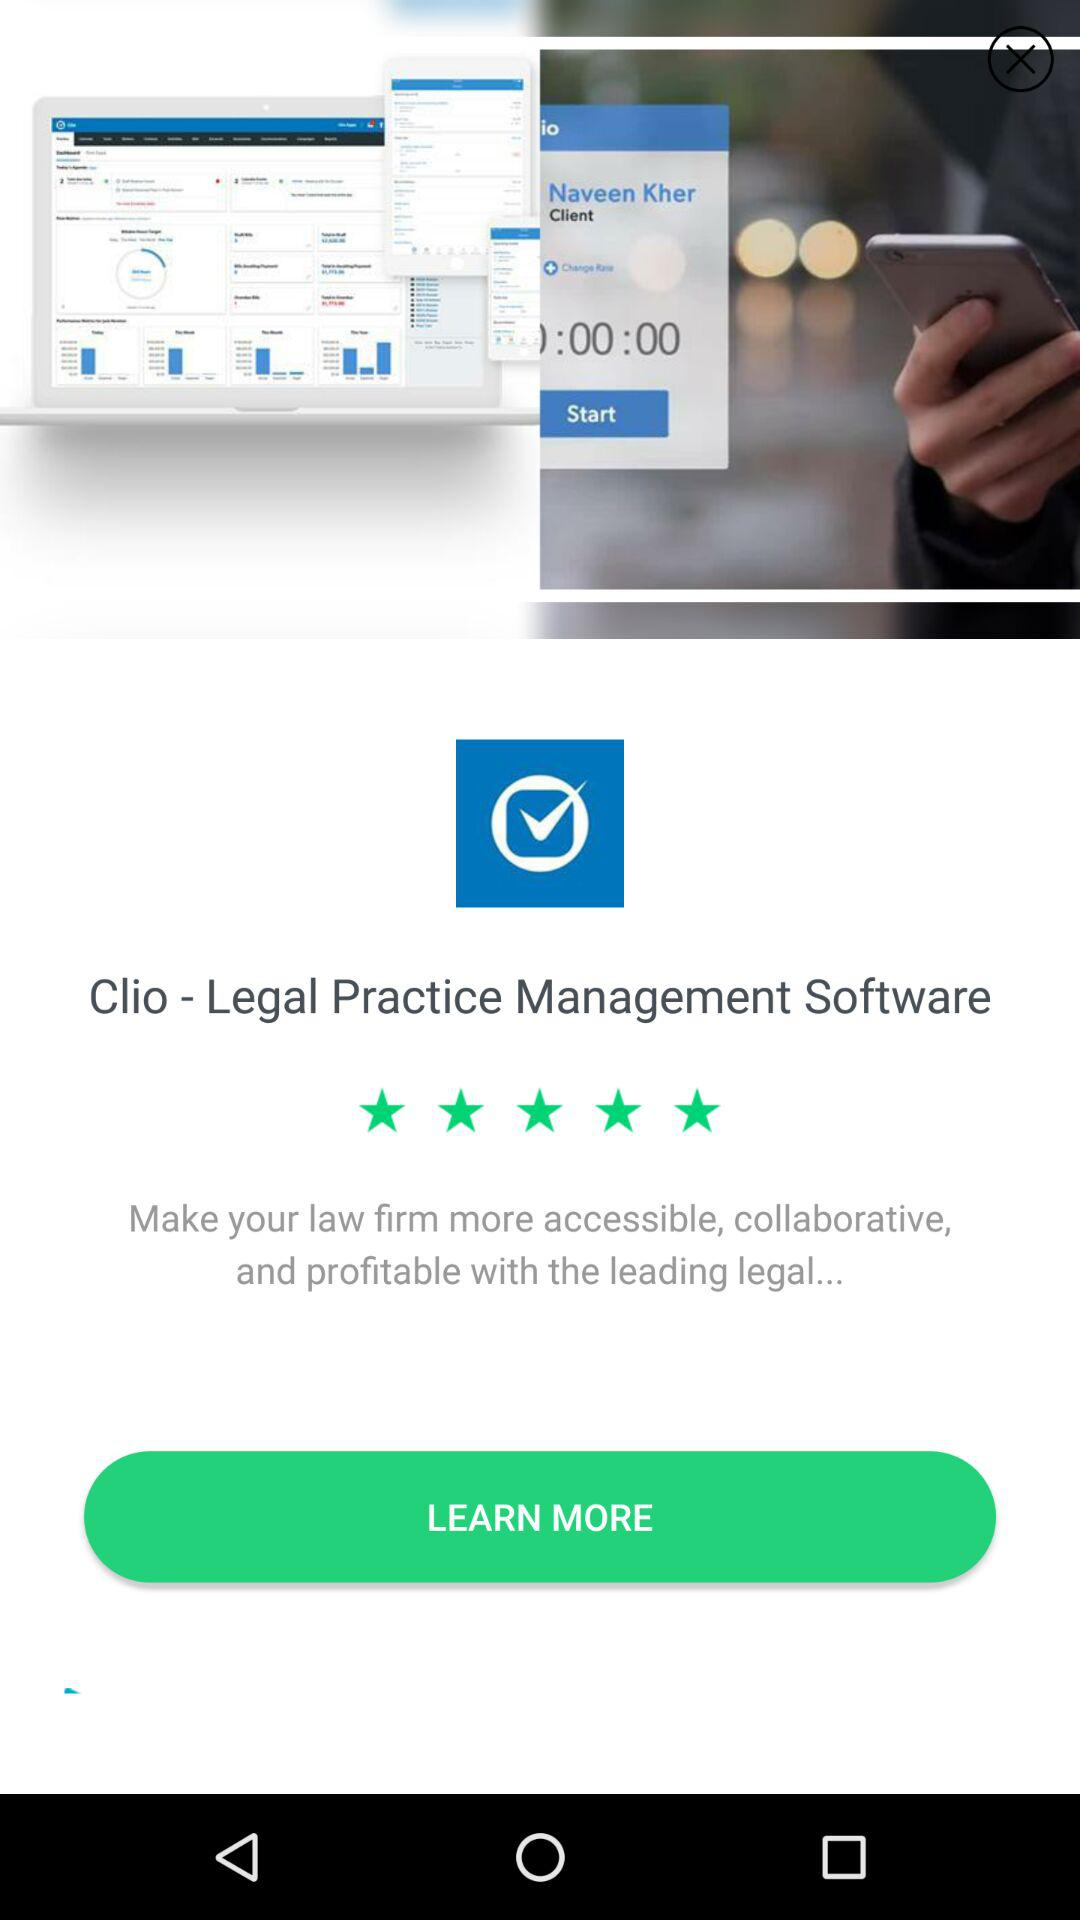How many seconds has the call been going on for?
Answer the question using a single word or phrase. 0 